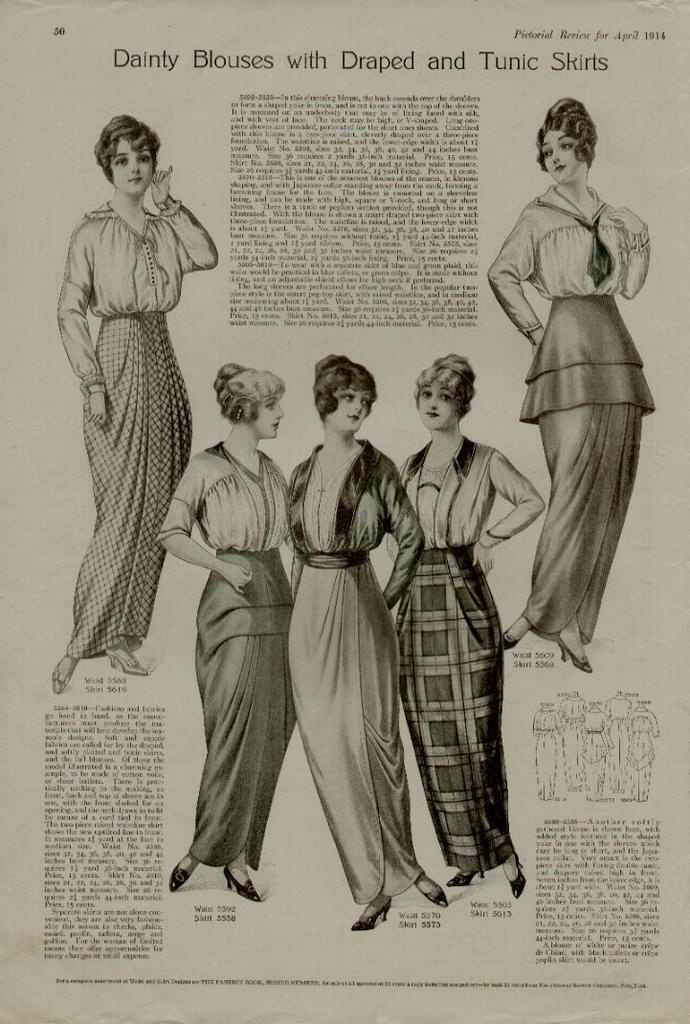What is happening in the image? There are persons standing in the image. Is there any text present in the image? Yes, there is text written on the image. What is the color scheme of the image? The image is in black and white. Can you see any sea creatures in the image? There are no sea creatures present in the image, as it is in black and white and features persons standing with text. 